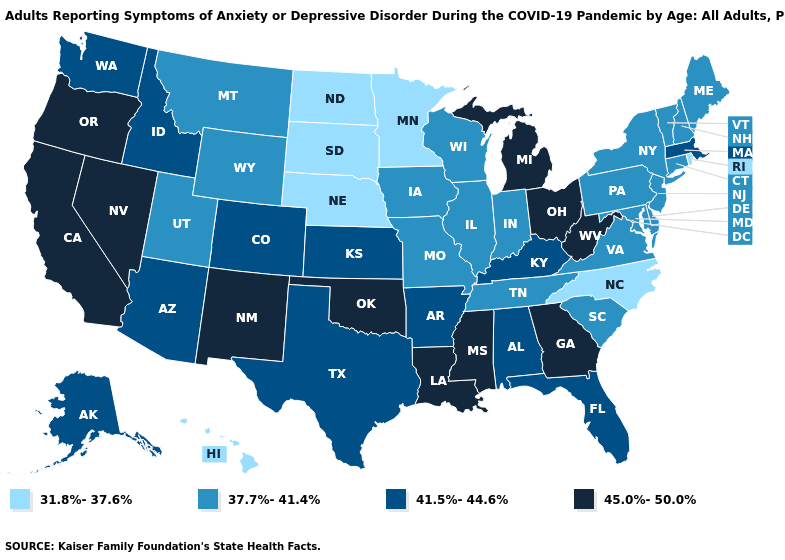Which states have the lowest value in the South?
Give a very brief answer. North Carolina. Name the states that have a value in the range 41.5%-44.6%?
Keep it brief. Alabama, Alaska, Arizona, Arkansas, Colorado, Florida, Idaho, Kansas, Kentucky, Massachusetts, Texas, Washington. Among the states that border Rhode Island , does Massachusetts have the lowest value?
Write a very short answer. No. Which states have the highest value in the USA?
Be succinct. California, Georgia, Louisiana, Michigan, Mississippi, Nevada, New Mexico, Ohio, Oklahoma, Oregon, West Virginia. Does the map have missing data?
Concise answer only. No. Does Massachusetts have the highest value in the Northeast?
Keep it brief. Yes. Does the map have missing data?
Write a very short answer. No. What is the value of Louisiana?
Give a very brief answer. 45.0%-50.0%. What is the value of North Dakota?
Answer briefly. 31.8%-37.6%. Does Rhode Island have a higher value than Vermont?
Be succinct. No. Among the states that border Kentucky , does Virginia have the highest value?
Be succinct. No. Does Hawaii have the lowest value in the West?
Write a very short answer. Yes. What is the lowest value in the USA?
Give a very brief answer. 31.8%-37.6%. What is the value of Alaska?
Answer briefly. 41.5%-44.6%. How many symbols are there in the legend?
Be succinct. 4. 